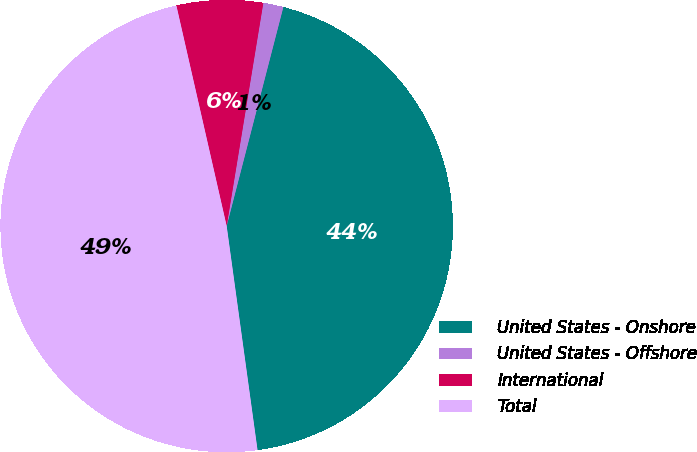Convert chart to OTSL. <chart><loc_0><loc_0><loc_500><loc_500><pie_chart><fcel>United States - Onshore<fcel>United States - Offshore<fcel>International<fcel>Total<nl><fcel>43.79%<fcel>1.44%<fcel>6.16%<fcel>48.61%<nl></chart> 